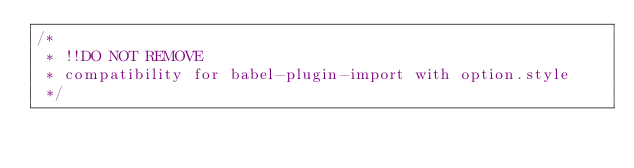<code> <loc_0><loc_0><loc_500><loc_500><_CSS_>/*
 * !!DO NOT REMOVE
 * compatibility for babel-plugin-import with option.style
 */</code> 